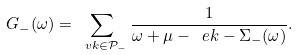Convert formula to latex. <formula><loc_0><loc_0><loc_500><loc_500>G _ { - } ( \omega ) = \sum _ { \ v k \in \mathcal { P } _ { - } } \frac { 1 } { \omega + \mu - \ e k - \Sigma _ { - } ( \omega ) } .</formula> 